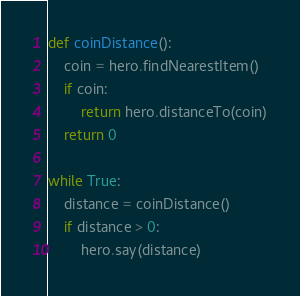<code> <loc_0><loc_0><loc_500><loc_500><_Python_>def coinDistance():
    coin = hero.findNearestItem()
    if coin:
        return hero.distanceTo(coin)
    return 0

while True:
    distance = coinDistance()
    if distance > 0:
        hero.say(distance)
</code> 